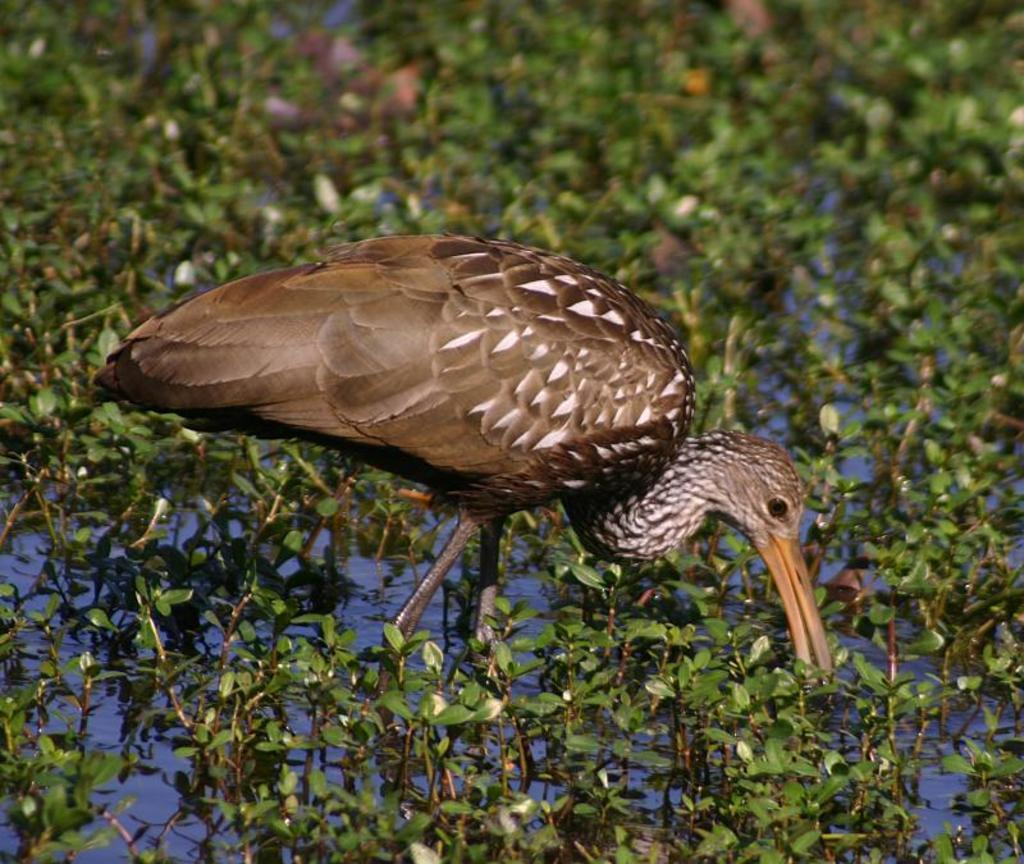What type of animal can be seen in the image? There is a bird in the image. Where is the bird located? The bird is in the water. What is the bird doing in the image? The bird is interacting with plants. What can be observed about the plants in the image? The plants have leaves. What type of tooth can be seen in the image? There is no tooth present in the image. Is there an airplane flying in the background of the image? There is no airplane visible in the image; it only features a bird interacting with plants in the water. 